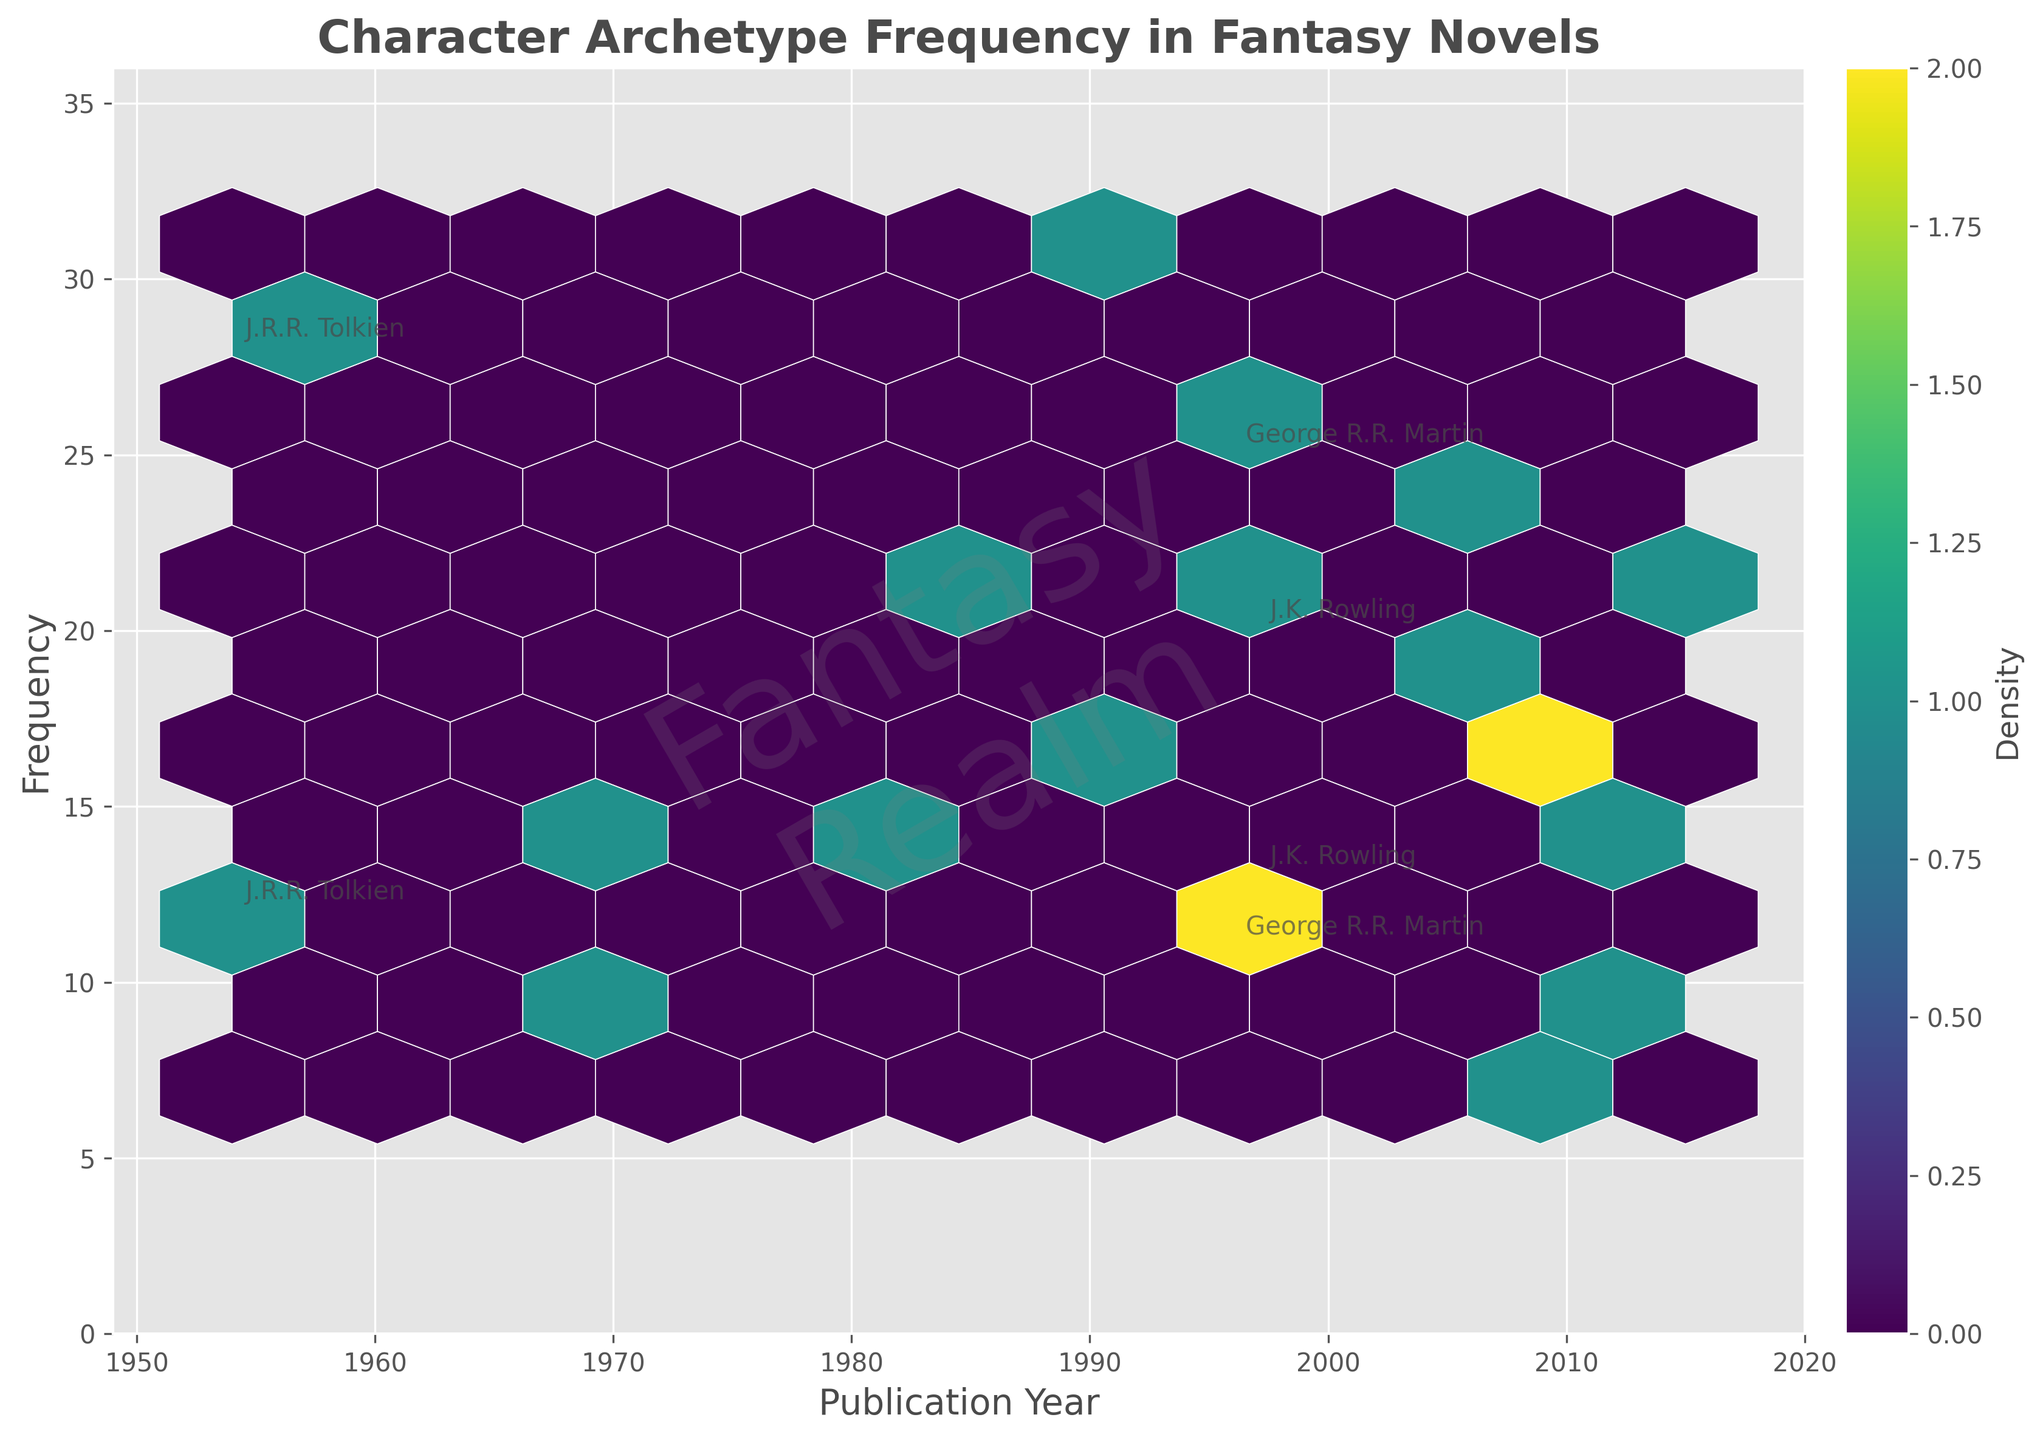What is the title of the plot? The title of the plot is usually displayed at the top of the figure. In this case, it reads "Character Archetype Frequency in Fantasy Novels".
Answer: Character Archetype Frequency in Fantasy Novels What do the x and y axis represent in the plot? The x-axis represents the publication year of the novels, while the y-axis represents the frequency of character archetypes. This information is displayed next to the respective axes.
Answer: Publication year and frequency Which author has annotated labels in the plot? The annotated labels highlight specific authors. On the figure, J.R.R. Tolkien, George R.R. Martin, and J.K. Rowling have labels next to their data points.
Answer: J.R.R. Tolkien, George R.R. Martin, J.K. Rowling How does the publication year range for the dataset? The range of years can be observed on the x-axis, which stretches from 1954 to 2015, including a small buffer.
Answer: 1954 to 2015 Which year has the highest archetype frequency in the plot? By examining the y-axis and locating the highest data point, we see that Robert Jordan's data point in 1990 reaches a frequency of 31, which is the highest on the plot.
Answer: 1990 What is the most common frequency range depicted in the plot? The color density provides insight into the frequency of data points clustered within certain ranges. Observing the color map, the most common frequencies fall between 10 and 20.
Answer: 10 to 20 How many shades of color are used to indicate different densities in the plot? The color bar on the side indicates the density, and by counting the number of different color graduations, we determine that there are approximately 10 shades used.
Answer: Around 10 Comparing J.R.R. Tolkien (1954) and Brandon Sanderson (2006), who depicts a higher frequency of archetypes? By comparing the data points, J.R.R. Tolkien's highest frequency is 28, whereas Brandon Sanderson's highest frequency is 23. J.R.R. Tolkien depicts a higher frequency.
Answer: J.R.R. Tolkien How does the density of archetype frequencies change over time? Observing the plot, the density is more concentrated in the middle years (1983-2007) with some scattered data points in the earlier (1954) and later years (2011-2015). This indicates a more active period for character archetypes in the middle range.
Answer: More concentrated in 1983-2007 Which author and year have the frequency closest to 20? By looking at the y-axis and identifying data points near 20, we see that N.K. Jemisin in 2015, depicting the 'Rebel' archetype, has a frequency of 21, which is closest to 20.
Answer: N.K. Jemisin in 2015 